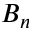Convert formula to latex. <formula><loc_0><loc_0><loc_500><loc_500>B _ { n }</formula> 